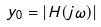Convert formula to latex. <formula><loc_0><loc_0><loc_500><loc_500>y _ { 0 } = | H ( j \omega ) |</formula> 